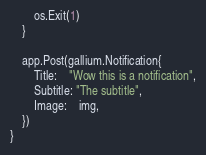<code> <loc_0><loc_0><loc_500><loc_500><_Go_>		os.Exit(1)
	}

	app.Post(gallium.Notification{
		Title:    "Wow this is a notification",
		Subtitle: "The subtitle",
		Image:    img,
	})
}
</code> 